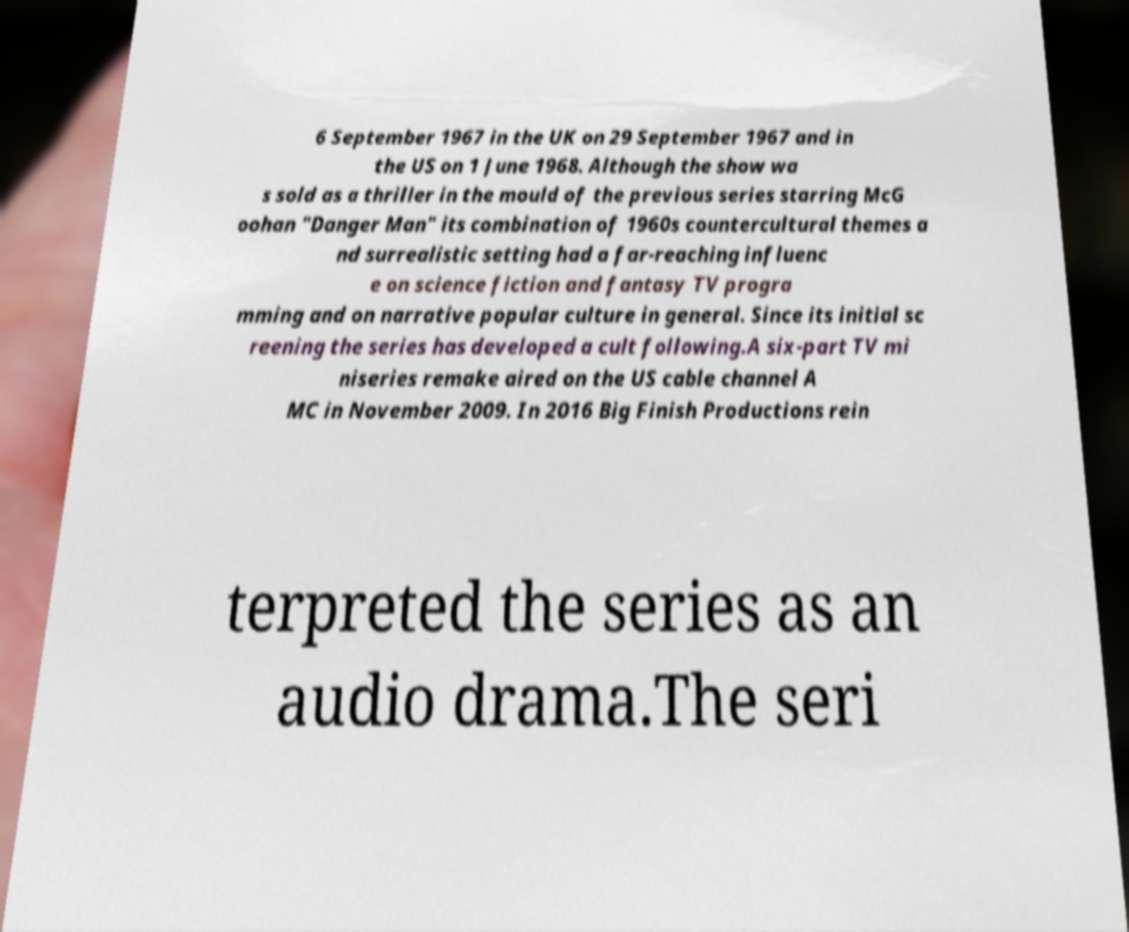I need the written content from this picture converted into text. Can you do that? 6 September 1967 in the UK on 29 September 1967 and in the US on 1 June 1968. Although the show wa s sold as a thriller in the mould of the previous series starring McG oohan "Danger Man" its combination of 1960s countercultural themes a nd surrealistic setting had a far-reaching influenc e on science fiction and fantasy TV progra mming and on narrative popular culture in general. Since its initial sc reening the series has developed a cult following.A six-part TV mi niseries remake aired on the US cable channel A MC in November 2009. In 2016 Big Finish Productions rein terpreted the series as an audio drama.The seri 